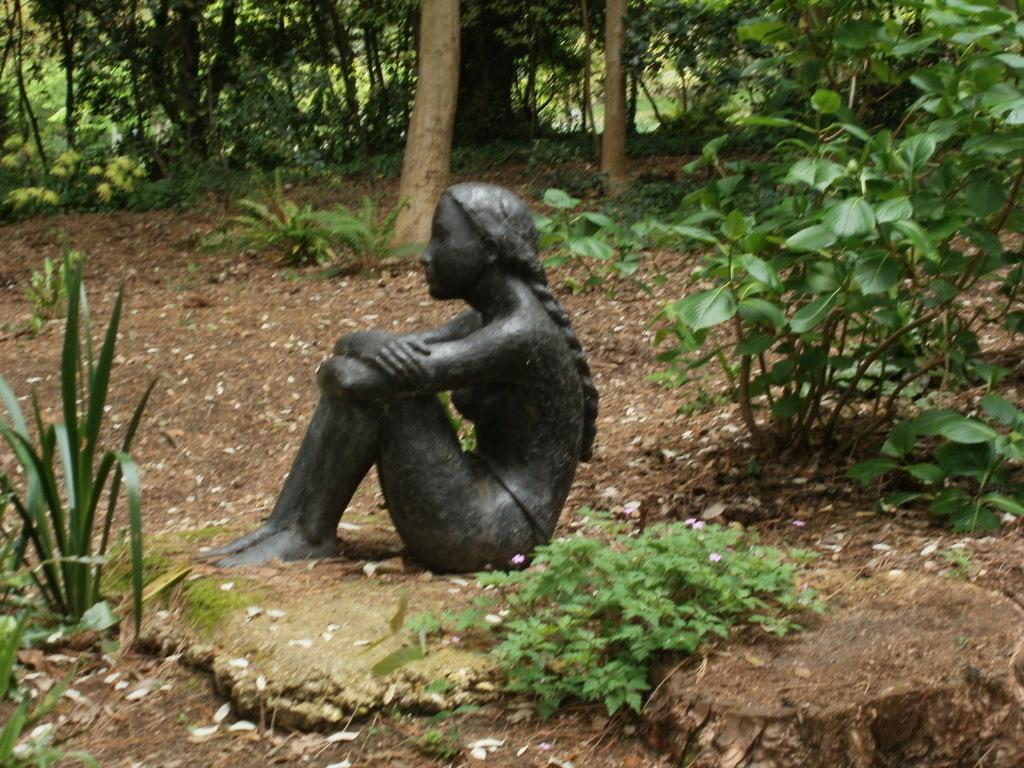What is the main subject in the picture? There is a statue in the picture. What other elements can be seen in the picture besides the statue? There are plants and trees in the picture. What book is the statue reading in the picture? There is no book or reading activity depicted in the image, as the statue is not a living being capable of reading. 